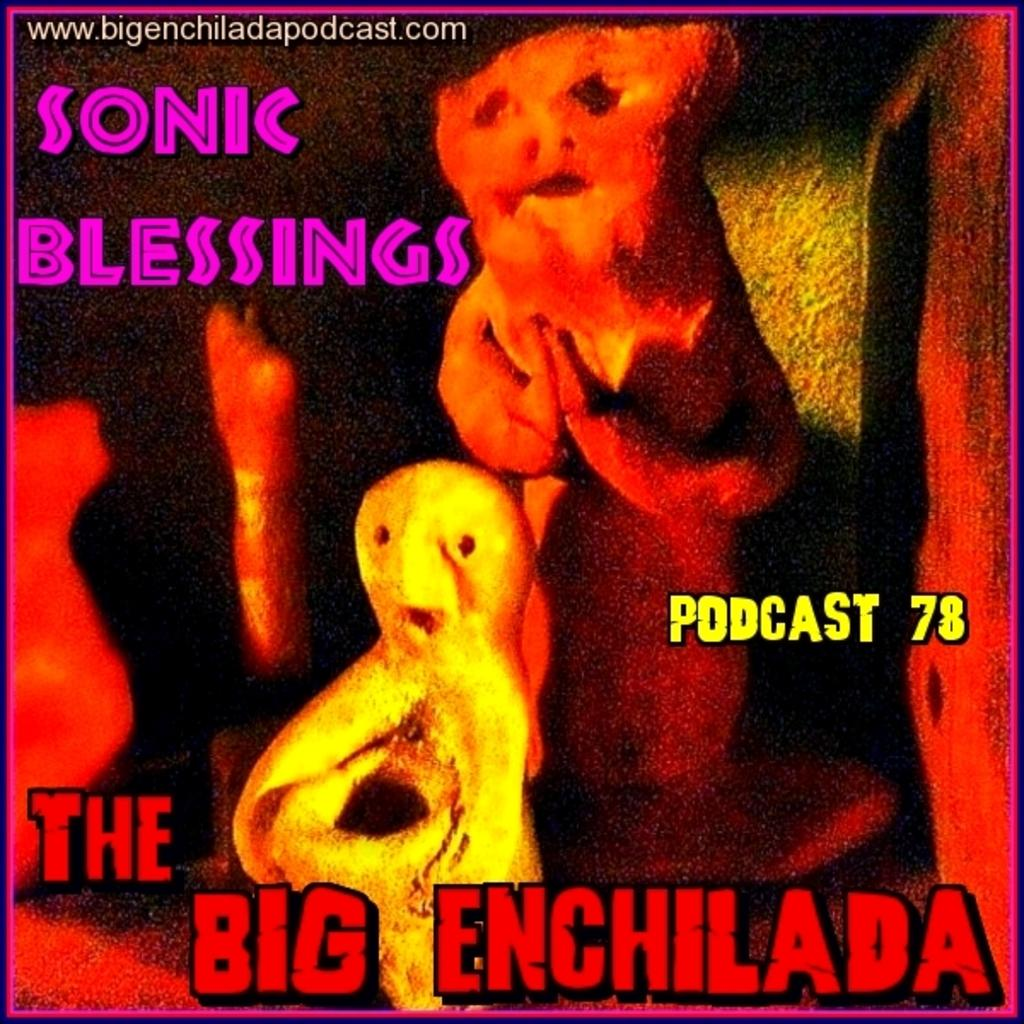<image>
Present a compact description of the photo's key features. Two statue looking figures with The Big Enchilada written on it 